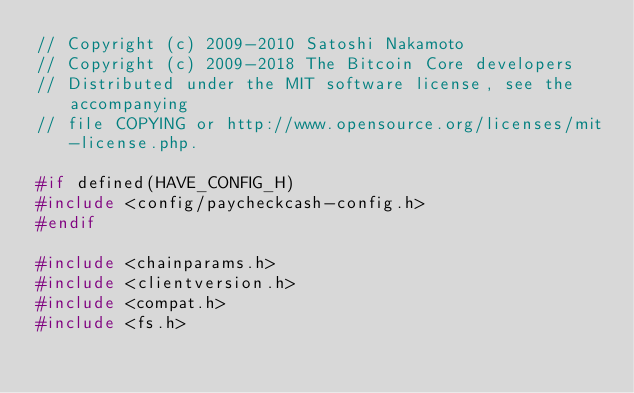Convert code to text. <code><loc_0><loc_0><loc_500><loc_500><_C++_>// Copyright (c) 2009-2010 Satoshi Nakamoto
// Copyright (c) 2009-2018 The Bitcoin Core developers
// Distributed under the MIT software license, see the accompanying
// file COPYING or http://www.opensource.org/licenses/mit-license.php.

#if defined(HAVE_CONFIG_H)
#include <config/paycheckcash-config.h>
#endif

#include <chainparams.h>
#include <clientversion.h>
#include <compat.h>
#include <fs.h></code> 